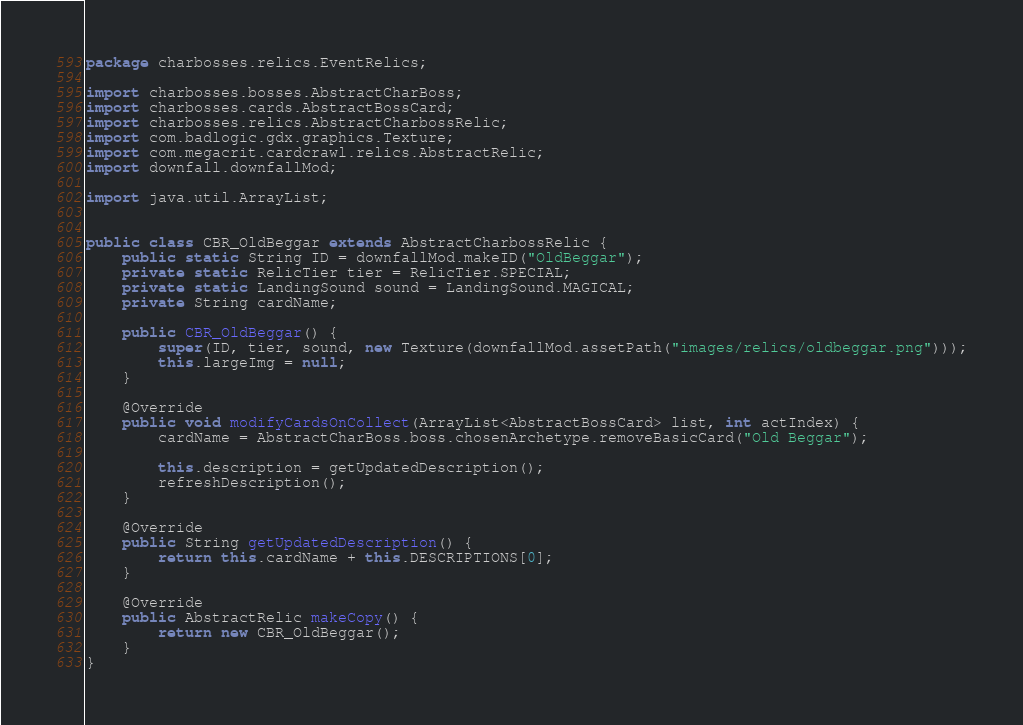Convert code to text. <code><loc_0><loc_0><loc_500><loc_500><_Java_>package charbosses.relics.EventRelics;

import charbosses.bosses.AbstractCharBoss;
import charbosses.cards.AbstractBossCard;
import charbosses.relics.AbstractCharbossRelic;
import com.badlogic.gdx.graphics.Texture;
import com.megacrit.cardcrawl.relics.AbstractRelic;
import downfall.downfallMod;

import java.util.ArrayList;


public class CBR_OldBeggar extends AbstractCharbossRelic {
    public static String ID = downfallMod.makeID("OldBeggar");
    private static RelicTier tier = RelicTier.SPECIAL;
    private static LandingSound sound = LandingSound.MAGICAL;
    private String cardName;

    public CBR_OldBeggar() {
        super(ID, tier, sound, new Texture(downfallMod.assetPath("images/relics/oldbeggar.png")));
        this.largeImg = null;
    }

    @Override
    public void modifyCardsOnCollect(ArrayList<AbstractBossCard> list, int actIndex) {
        cardName = AbstractCharBoss.boss.chosenArchetype.removeBasicCard("Old Beggar");

        this.description = getUpdatedDescription();
        refreshDescription();
    }

    @Override
    public String getUpdatedDescription() {
        return this.cardName + this.DESCRIPTIONS[0];
    }

    @Override
    public AbstractRelic makeCopy() {
        return new CBR_OldBeggar();
    }
}
</code> 